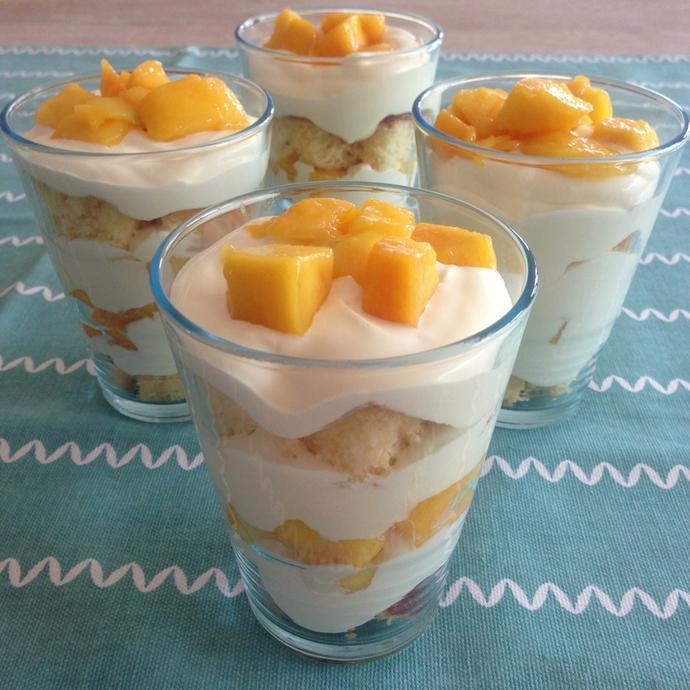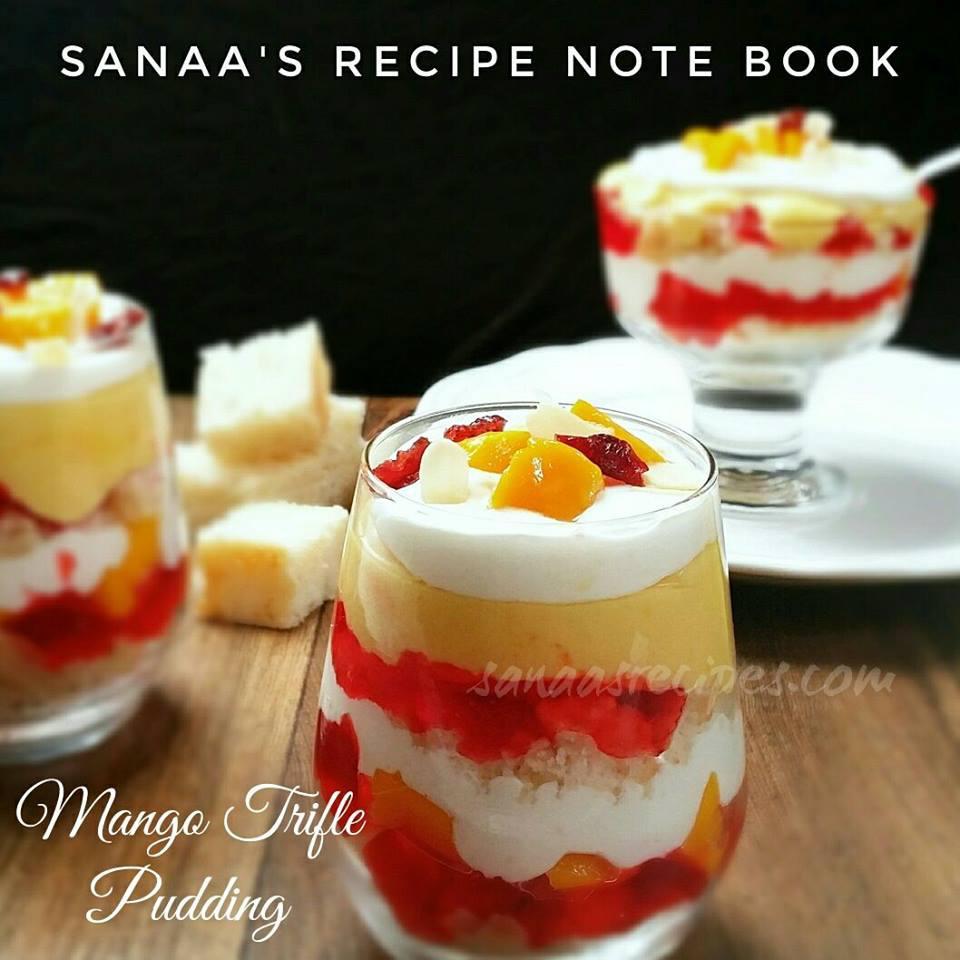The first image is the image on the left, the second image is the image on the right. Examine the images to the left and right. Is the description "there are 2 parfaits on the right image" accurate? Answer yes or no. Yes. 